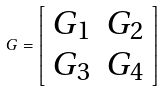Convert formula to latex. <formula><loc_0><loc_0><loc_500><loc_500>G = \left [ \begin{array} { c c } G _ { 1 } & G _ { 2 } \\ G _ { 3 } & G _ { 4 } \end{array} \right ]</formula> 